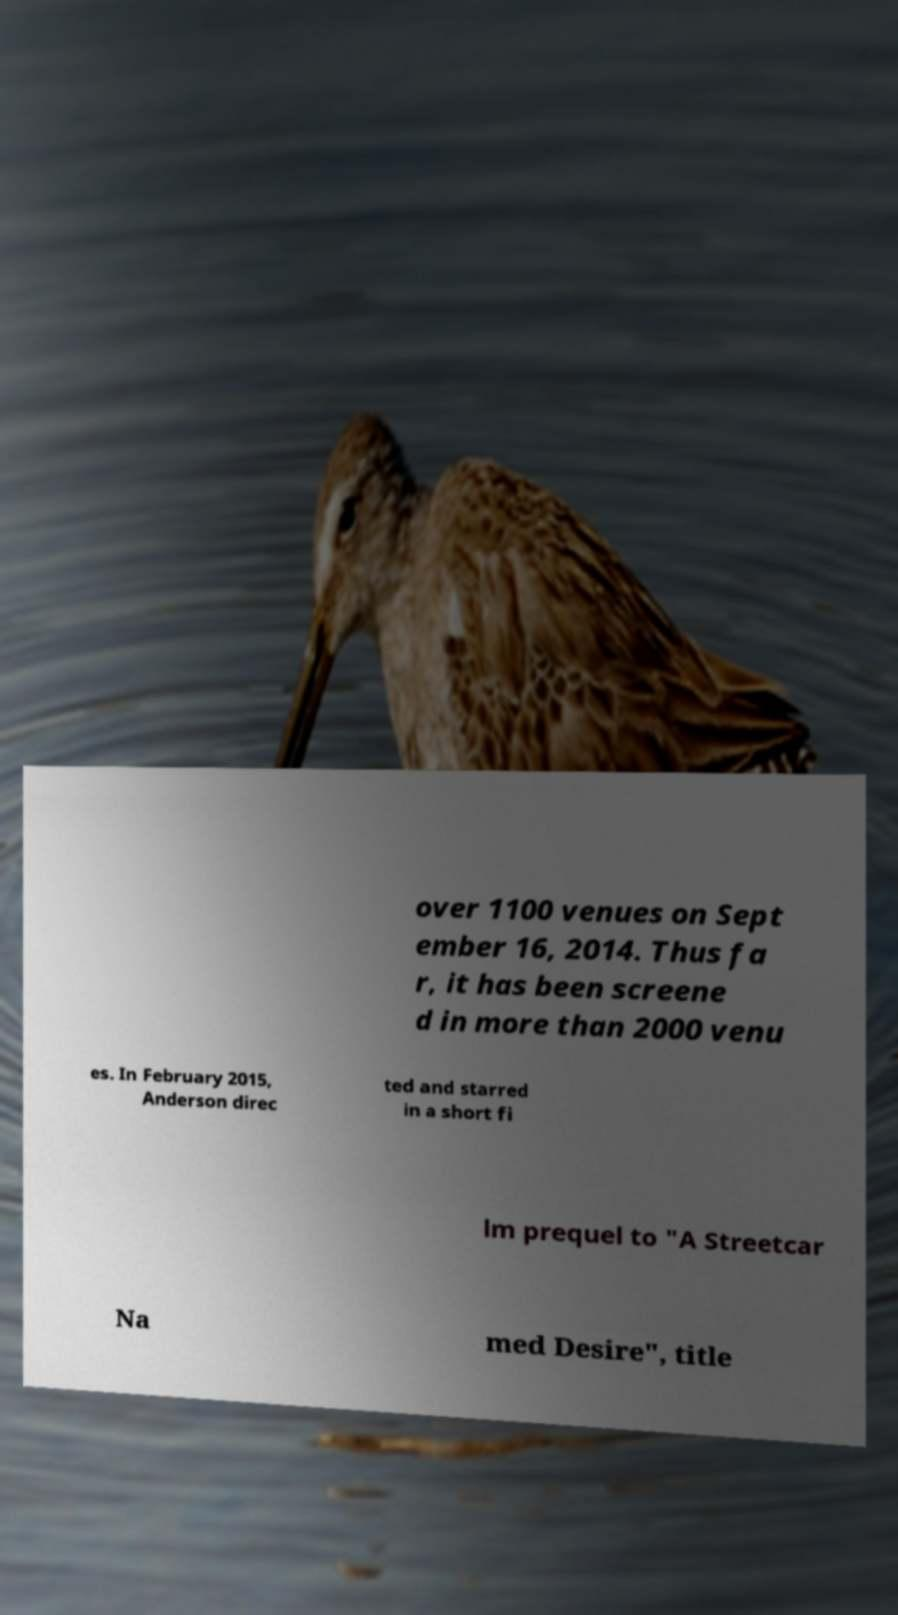For documentation purposes, I need the text within this image transcribed. Could you provide that? over 1100 venues on Sept ember 16, 2014. Thus fa r, it has been screene d in more than 2000 venu es. In February 2015, Anderson direc ted and starred in a short fi lm prequel to "A Streetcar Na med Desire", title 